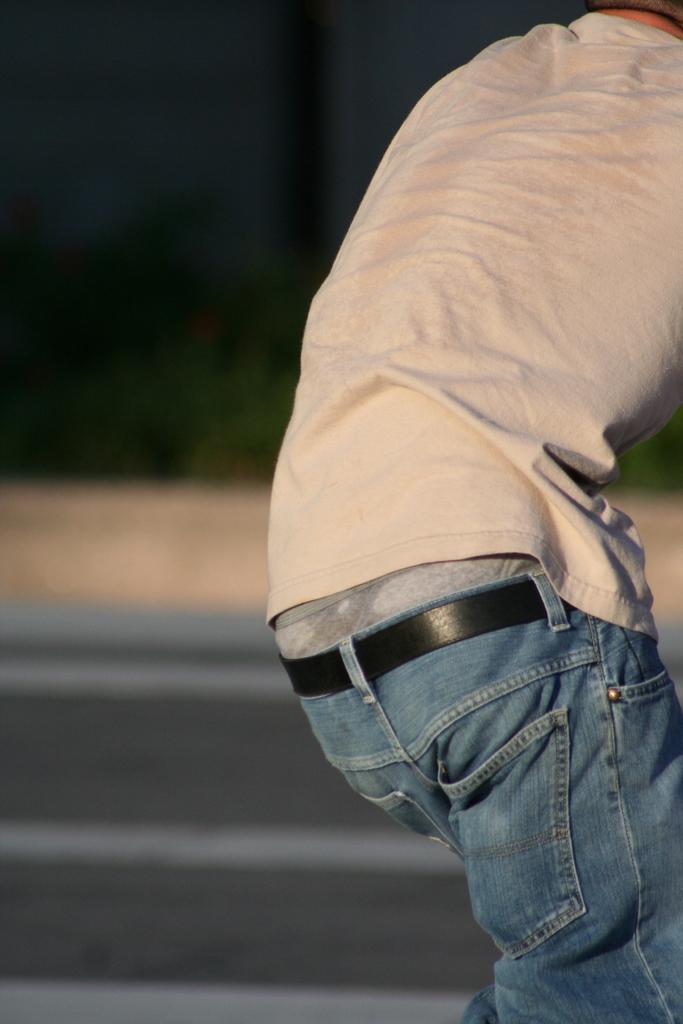Can you describe this image briefly? In the foreground of the image there is a person. The background of the image is blurred. At the bottom of the image there is road. 